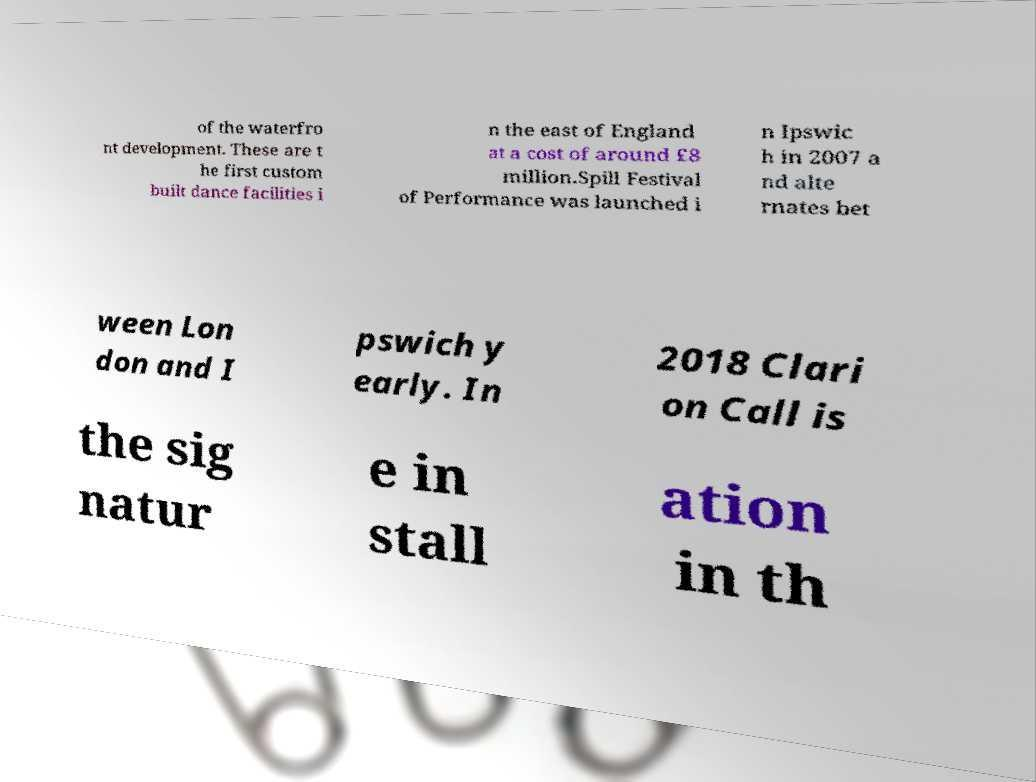Please read and relay the text visible in this image. What does it say? of the waterfro nt development. These are t he first custom built dance facilities i n the east of England at a cost of around £8 million.Spill Festival of Performance was launched i n Ipswic h in 2007 a nd alte rnates bet ween Lon don and I pswich y early. In 2018 Clari on Call is the sig natur e in stall ation in th 